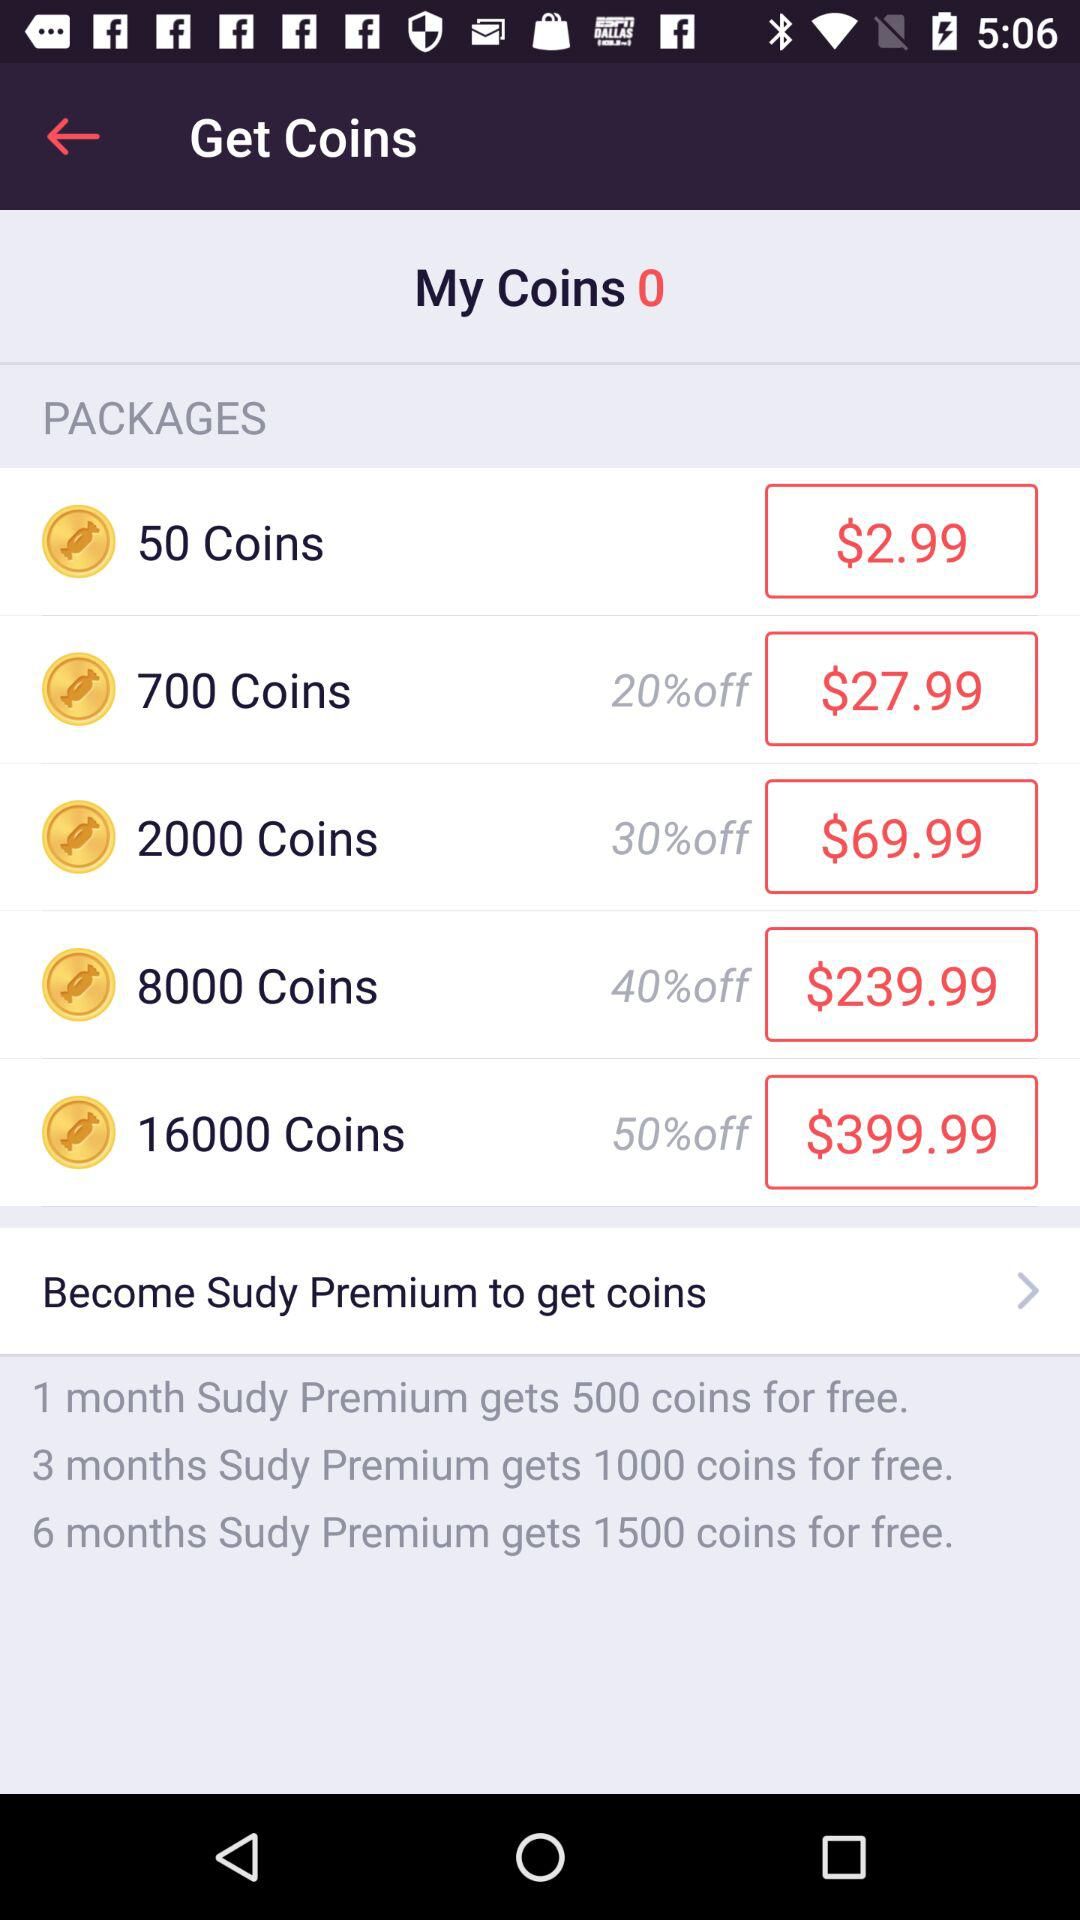How many coins do you get for free if you subscribe to Sudy Premium for 6 months?
Answer the question using a single word or phrase. 1500 